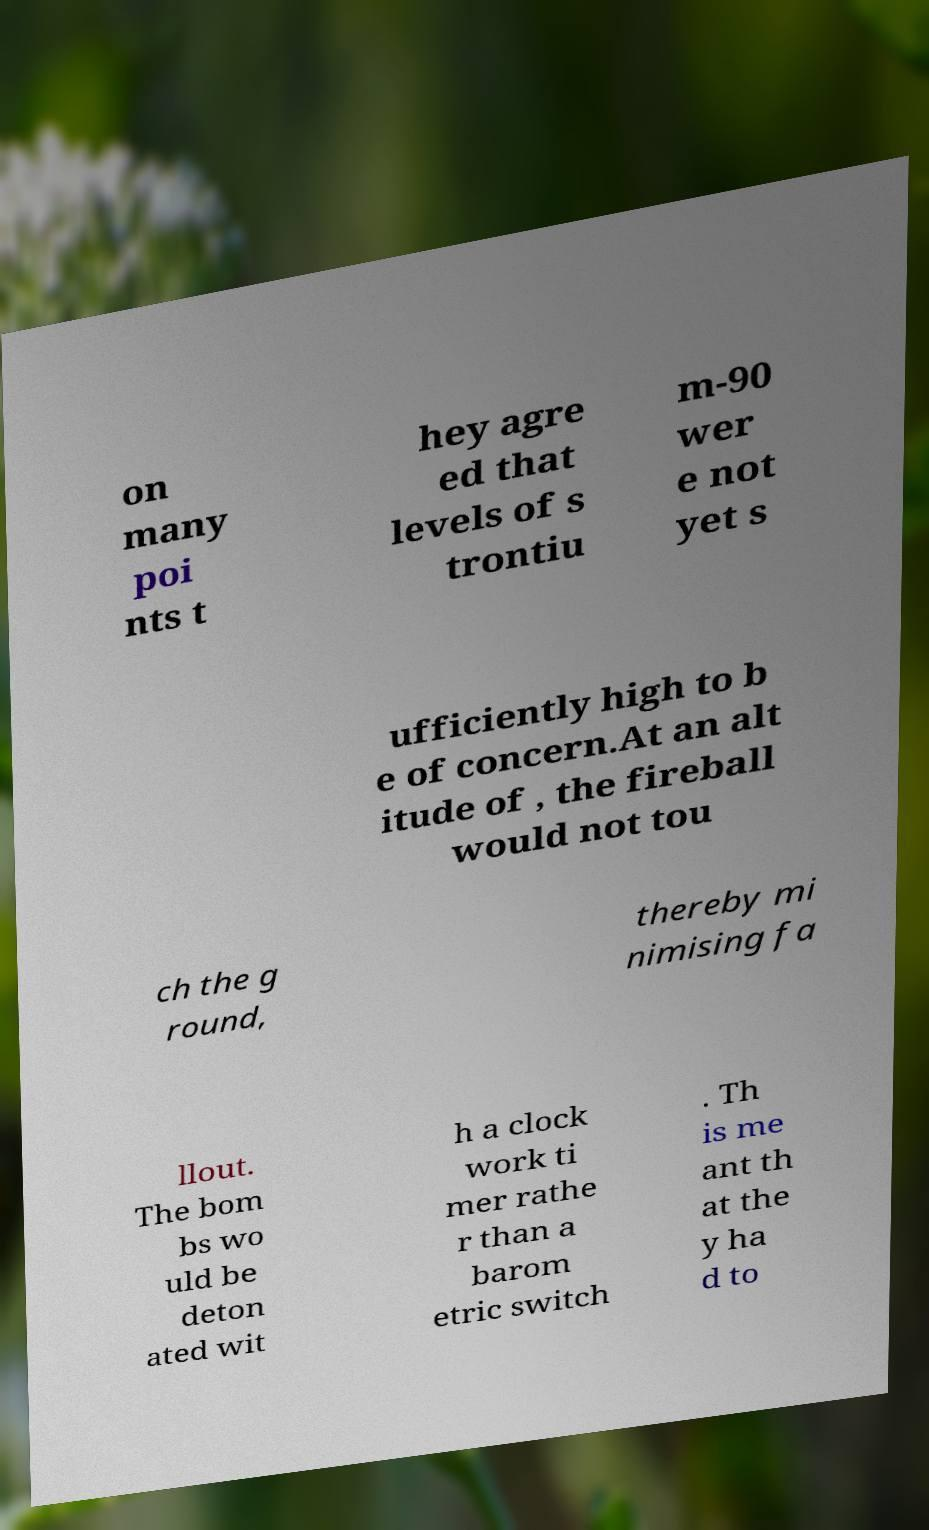Could you assist in decoding the text presented in this image and type it out clearly? on many poi nts t hey agre ed that levels of s trontiu m-90 wer e not yet s ufficiently high to b e of concern.At an alt itude of , the fireball would not tou ch the g round, thereby mi nimising fa llout. The bom bs wo uld be deton ated wit h a clock work ti mer rathe r than a barom etric switch . Th is me ant th at the y ha d to 